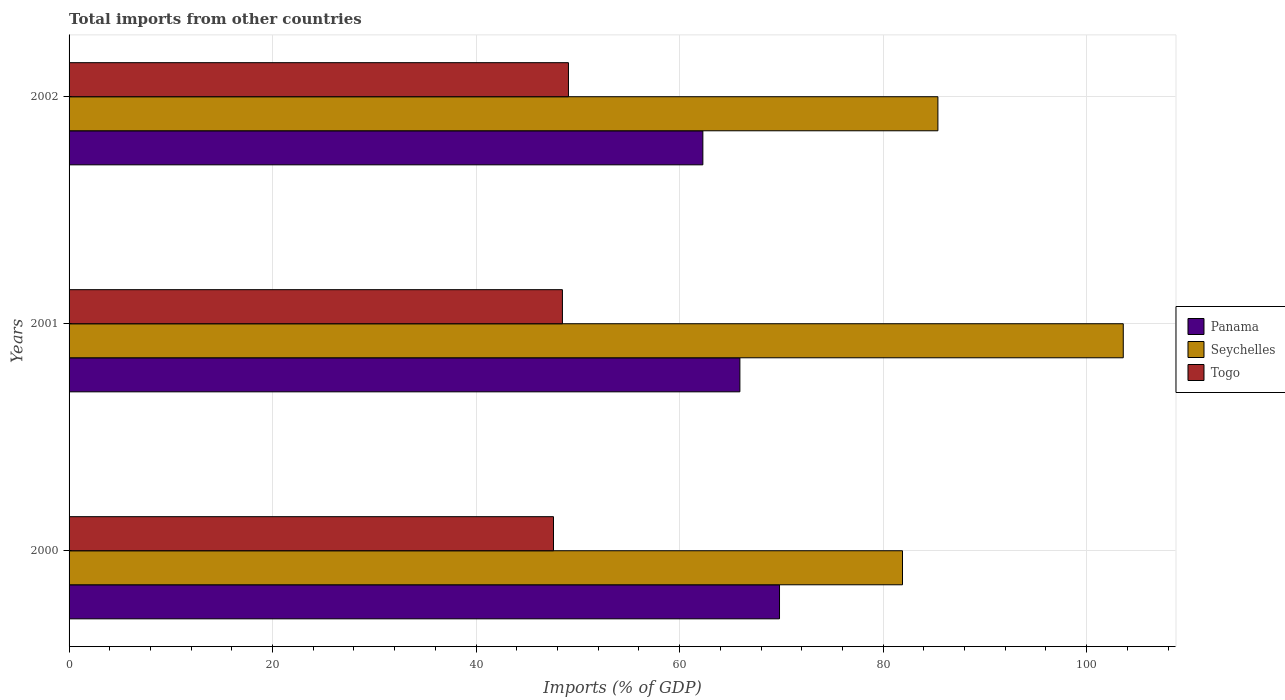Are the number of bars on each tick of the Y-axis equal?
Your response must be concise. Yes. What is the label of the 2nd group of bars from the top?
Give a very brief answer. 2001. In how many cases, is the number of bars for a given year not equal to the number of legend labels?
Make the answer very short. 0. What is the total imports in Panama in 2000?
Offer a very short reply. 69.82. Across all years, what is the maximum total imports in Togo?
Your answer should be very brief. 49.08. Across all years, what is the minimum total imports in Togo?
Ensure brevity in your answer.  47.61. In which year was the total imports in Togo minimum?
Provide a succinct answer. 2000. What is the total total imports in Togo in the graph?
Provide a succinct answer. 145.17. What is the difference between the total imports in Togo in 2000 and that in 2001?
Keep it short and to the point. -0.88. What is the difference between the total imports in Panama in 2001 and the total imports in Seychelles in 2002?
Give a very brief answer. -19.46. What is the average total imports in Panama per year?
Give a very brief answer. 66.01. In the year 2001, what is the difference between the total imports in Seychelles and total imports in Togo?
Your answer should be compact. 55.12. What is the ratio of the total imports in Panama in 2001 to that in 2002?
Your answer should be compact. 1.06. Is the total imports in Panama in 2000 less than that in 2002?
Provide a succinct answer. No. Is the difference between the total imports in Seychelles in 2000 and 2002 greater than the difference between the total imports in Togo in 2000 and 2002?
Offer a terse response. No. What is the difference between the highest and the second highest total imports in Panama?
Give a very brief answer. 3.9. What is the difference between the highest and the lowest total imports in Panama?
Provide a succinct answer. 7.53. What does the 1st bar from the top in 2000 represents?
Provide a short and direct response. Togo. What does the 3rd bar from the bottom in 2001 represents?
Your response must be concise. Togo. Is it the case that in every year, the sum of the total imports in Panama and total imports in Seychelles is greater than the total imports in Togo?
Your answer should be compact. Yes. How many years are there in the graph?
Offer a terse response. 3. What is the difference between two consecutive major ticks on the X-axis?
Offer a terse response. 20. Are the values on the major ticks of X-axis written in scientific E-notation?
Provide a short and direct response. No. How are the legend labels stacked?
Your answer should be very brief. Vertical. What is the title of the graph?
Give a very brief answer. Total imports from other countries. What is the label or title of the X-axis?
Provide a short and direct response. Imports (% of GDP). What is the label or title of the Y-axis?
Keep it short and to the point. Years. What is the Imports (% of GDP) of Panama in 2000?
Give a very brief answer. 69.82. What is the Imports (% of GDP) in Seychelles in 2000?
Ensure brevity in your answer.  81.9. What is the Imports (% of GDP) of Togo in 2000?
Your response must be concise. 47.61. What is the Imports (% of GDP) in Panama in 2001?
Your answer should be very brief. 65.92. What is the Imports (% of GDP) of Seychelles in 2001?
Make the answer very short. 103.6. What is the Imports (% of GDP) in Togo in 2001?
Ensure brevity in your answer.  48.48. What is the Imports (% of GDP) of Panama in 2002?
Offer a very short reply. 62.29. What is the Imports (% of GDP) of Seychelles in 2002?
Keep it short and to the point. 85.38. What is the Imports (% of GDP) of Togo in 2002?
Your answer should be very brief. 49.08. Across all years, what is the maximum Imports (% of GDP) in Panama?
Give a very brief answer. 69.82. Across all years, what is the maximum Imports (% of GDP) in Seychelles?
Ensure brevity in your answer.  103.6. Across all years, what is the maximum Imports (% of GDP) in Togo?
Keep it short and to the point. 49.08. Across all years, what is the minimum Imports (% of GDP) of Panama?
Keep it short and to the point. 62.29. Across all years, what is the minimum Imports (% of GDP) in Seychelles?
Your response must be concise. 81.9. Across all years, what is the minimum Imports (% of GDP) of Togo?
Keep it short and to the point. 47.61. What is the total Imports (% of GDP) of Panama in the graph?
Give a very brief answer. 198.03. What is the total Imports (% of GDP) of Seychelles in the graph?
Give a very brief answer. 270.89. What is the total Imports (% of GDP) in Togo in the graph?
Offer a terse response. 145.17. What is the difference between the Imports (% of GDP) in Panama in 2000 and that in 2001?
Provide a succinct answer. 3.9. What is the difference between the Imports (% of GDP) in Seychelles in 2000 and that in 2001?
Offer a terse response. -21.7. What is the difference between the Imports (% of GDP) of Togo in 2000 and that in 2001?
Give a very brief answer. -0.88. What is the difference between the Imports (% of GDP) in Panama in 2000 and that in 2002?
Give a very brief answer. 7.53. What is the difference between the Imports (% of GDP) of Seychelles in 2000 and that in 2002?
Make the answer very short. -3.48. What is the difference between the Imports (% of GDP) in Togo in 2000 and that in 2002?
Your answer should be very brief. -1.47. What is the difference between the Imports (% of GDP) in Panama in 2001 and that in 2002?
Ensure brevity in your answer.  3.64. What is the difference between the Imports (% of GDP) in Seychelles in 2001 and that in 2002?
Offer a very short reply. 18.22. What is the difference between the Imports (% of GDP) in Togo in 2001 and that in 2002?
Offer a very short reply. -0.59. What is the difference between the Imports (% of GDP) in Panama in 2000 and the Imports (% of GDP) in Seychelles in 2001?
Give a very brief answer. -33.78. What is the difference between the Imports (% of GDP) in Panama in 2000 and the Imports (% of GDP) in Togo in 2001?
Provide a succinct answer. 21.33. What is the difference between the Imports (% of GDP) of Seychelles in 2000 and the Imports (% of GDP) of Togo in 2001?
Offer a terse response. 33.42. What is the difference between the Imports (% of GDP) of Panama in 2000 and the Imports (% of GDP) of Seychelles in 2002?
Your response must be concise. -15.57. What is the difference between the Imports (% of GDP) of Panama in 2000 and the Imports (% of GDP) of Togo in 2002?
Offer a terse response. 20.74. What is the difference between the Imports (% of GDP) in Seychelles in 2000 and the Imports (% of GDP) in Togo in 2002?
Your answer should be compact. 32.83. What is the difference between the Imports (% of GDP) in Panama in 2001 and the Imports (% of GDP) in Seychelles in 2002?
Give a very brief answer. -19.46. What is the difference between the Imports (% of GDP) of Panama in 2001 and the Imports (% of GDP) of Togo in 2002?
Keep it short and to the point. 16.85. What is the difference between the Imports (% of GDP) in Seychelles in 2001 and the Imports (% of GDP) in Togo in 2002?
Provide a succinct answer. 54.52. What is the average Imports (% of GDP) of Panama per year?
Keep it short and to the point. 66.01. What is the average Imports (% of GDP) of Seychelles per year?
Offer a terse response. 90.3. What is the average Imports (% of GDP) in Togo per year?
Offer a very short reply. 48.39. In the year 2000, what is the difference between the Imports (% of GDP) of Panama and Imports (% of GDP) of Seychelles?
Your answer should be compact. -12.09. In the year 2000, what is the difference between the Imports (% of GDP) in Panama and Imports (% of GDP) in Togo?
Provide a succinct answer. 22.21. In the year 2000, what is the difference between the Imports (% of GDP) in Seychelles and Imports (% of GDP) in Togo?
Provide a short and direct response. 34.3. In the year 2001, what is the difference between the Imports (% of GDP) of Panama and Imports (% of GDP) of Seychelles?
Give a very brief answer. -37.68. In the year 2001, what is the difference between the Imports (% of GDP) in Panama and Imports (% of GDP) in Togo?
Offer a very short reply. 17.44. In the year 2001, what is the difference between the Imports (% of GDP) in Seychelles and Imports (% of GDP) in Togo?
Your answer should be very brief. 55.12. In the year 2002, what is the difference between the Imports (% of GDP) of Panama and Imports (% of GDP) of Seychelles?
Your answer should be compact. -23.1. In the year 2002, what is the difference between the Imports (% of GDP) of Panama and Imports (% of GDP) of Togo?
Your answer should be compact. 13.21. In the year 2002, what is the difference between the Imports (% of GDP) in Seychelles and Imports (% of GDP) in Togo?
Provide a short and direct response. 36.31. What is the ratio of the Imports (% of GDP) in Panama in 2000 to that in 2001?
Offer a terse response. 1.06. What is the ratio of the Imports (% of GDP) in Seychelles in 2000 to that in 2001?
Make the answer very short. 0.79. What is the ratio of the Imports (% of GDP) in Togo in 2000 to that in 2001?
Make the answer very short. 0.98. What is the ratio of the Imports (% of GDP) of Panama in 2000 to that in 2002?
Your answer should be very brief. 1.12. What is the ratio of the Imports (% of GDP) in Seychelles in 2000 to that in 2002?
Your answer should be compact. 0.96. What is the ratio of the Imports (% of GDP) of Panama in 2001 to that in 2002?
Provide a short and direct response. 1.06. What is the ratio of the Imports (% of GDP) in Seychelles in 2001 to that in 2002?
Your answer should be compact. 1.21. What is the ratio of the Imports (% of GDP) of Togo in 2001 to that in 2002?
Provide a short and direct response. 0.99. What is the difference between the highest and the second highest Imports (% of GDP) of Panama?
Ensure brevity in your answer.  3.9. What is the difference between the highest and the second highest Imports (% of GDP) of Seychelles?
Offer a very short reply. 18.22. What is the difference between the highest and the second highest Imports (% of GDP) in Togo?
Your answer should be compact. 0.59. What is the difference between the highest and the lowest Imports (% of GDP) in Panama?
Make the answer very short. 7.53. What is the difference between the highest and the lowest Imports (% of GDP) of Seychelles?
Provide a short and direct response. 21.7. What is the difference between the highest and the lowest Imports (% of GDP) in Togo?
Give a very brief answer. 1.47. 